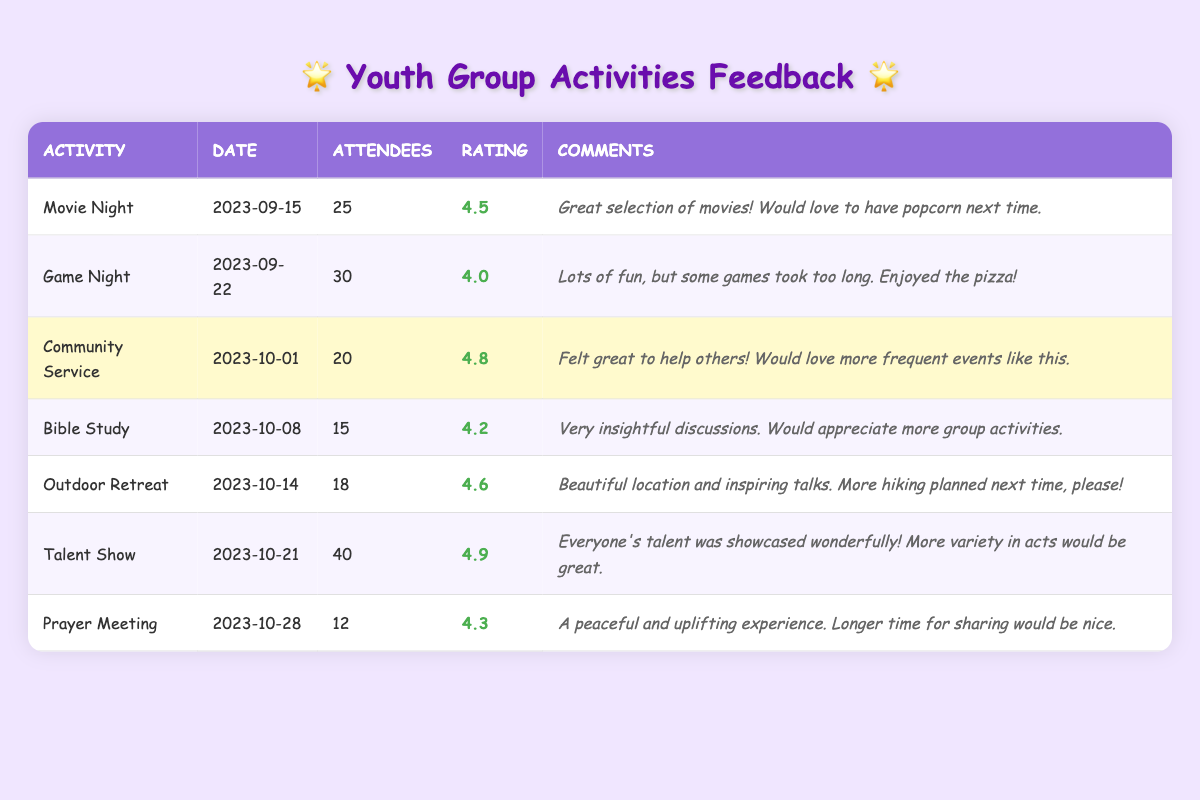What was the highest rating activity? The highest rating in the table is for the "Talent Show," which received an average rating of 4.9.
Answer: Talent Show How many people attended the "Game Night"? The "Game Night" had a total of 30 attendees as shown in the table.
Answer: 30 Did the "Prayer Meeting" have more attendees than the "Bible Study"? Yes, the "Prayer Meeting" had 12 attendees, while the "Bible Study" had 15 attendees. Since 12 is not greater than 15, the statement is false.
Answer: No What is the average rating of all activities listed in the table? To find the average, add all the ratings: (4.5 + 4.0 + 4.8 + 4.2 + 4.6 + 4.9 + 4.3) = 26.3. Since there are 7 activities, divide by 7: 26.3 / 7 = 3.757, which rounds to 3.76.
Answer: 3.76 Which activity had the lowest average rating? The "Game Night" has the lowest average rating of 4.0 when comparing all ratings from the table.
Answer: Game Night How many total attendees participated in the "Outdoor Retreat" and "Community Service" combined? The "Outdoor Retreat" had 18 attendees, and "Community Service" had 20 attendees. Adding them together gives 18 + 20 = 38.
Answer: 38 Was the average rating of "Bible Study" higher than 4.2? The average rating for "Bible Study" is 4.2, which means it is not higher than 4.2; it is equal.
Answer: No What feedback did attendees provide for "Movie Night"? The comments for "Movie Night" included: "Great selection of movies!" and "Would love to have popcorn next time."
Answer: Great selection of movies! Would love to have popcorn next time Which event had the most attendees? The event with the most attendees was the "Talent Show," which had 40 attendees, as indicated in the table.
Answer: Talent Show How many activities had an average rating of above 4.5? The activities with an average rating above 4.5 are "Community Service" (4.8), "Outdoor Retreat" (4.6), and "Talent Show" (4.9), totaling 3 activities.
Answer: 3 